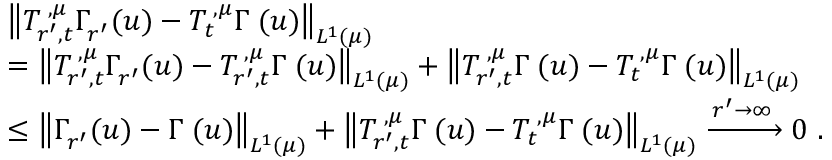<formula> <loc_0><loc_0><loc_500><loc_500>\begin{array} { r l } & { \left \| T _ { r ^ { \prime } , t } ^ { { \mathbf \Upsilon } , { \mu } } \Gamma _ { r ^ { \prime } } ^ { \mathbf \Upsilon } ( u ) - T _ { t } ^ { { \mathbf \Upsilon } , { \mu } } \Gamma ^ { \mathbf \Upsilon } ( u ) \right \| _ { L ^ { 1 } ( { \mu } ) } } \\ & { = \left \| T _ { r ^ { \prime } , t } ^ { { \mathbf \Upsilon } , { \mu } } \Gamma _ { r ^ { \prime } } ^ { \mathbf \Upsilon } ( u ) - T _ { r ^ { \prime } , t } ^ { { \mathbf \Upsilon } , { \mu } } \Gamma ^ { \mathbf \Upsilon } ( u ) \right \| _ { L ^ { 1 } ( { \mu } ) } + \left \| T _ { r ^ { \prime } , t } ^ { { \mathbf \Upsilon } , { \mu } } \Gamma ^ { \mathbf \Upsilon } ( u ) - T _ { t } ^ { { \mathbf \Upsilon } , { \mu } } \Gamma ^ { \mathbf \Upsilon } ( u ) \right \| _ { L ^ { 1 } ( { \mu } ) } } \\ & { \leq \left \| \Gamma _ { r ^ { \prime } } ^ { \mathbf \Upsilon } ( u ) - \Gamma ^ { \mathbf \Upsilon } ( u ) \right \| _ { L ^ { 1 } ( { \mu } ) } + \left \| T _ { r ^ { \prime } , t } ^ { { \mathbf \Upsilon } , { \mu } } \Gamma ^ { \mathbf \Upsilon } ( u ) - T _ { t } ^ { { \mathbf \Upsilon } , { \mu } } \Gamma ^ { \mathbf \Upsilon } ( u ) \right \| _ { L ^ { 1 } ( { \mu } ) } \xrightarrow { r ^ { \prime } \to \infty } 0 \, . } \end{array}</formula> 